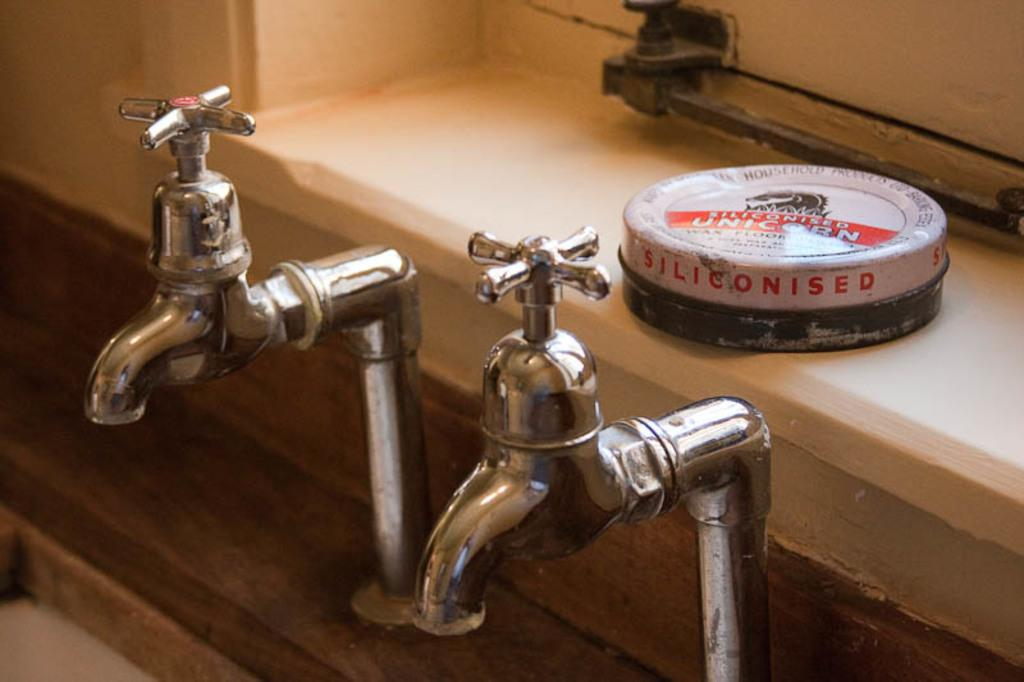How many taps are visible in the image? There are two taps in the image. What else can be seen in the image besides the taps? There is a box on a platform in the image. What type of smile can be seen on the box in the image? There is no smile present on the box in the image, as it is an inanimate object. 